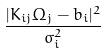<formula> <loc_0><loc_0><loc_500><loc_500>\frac { | K _ { i j } \Omega _ { j } - b _ { i } | ^ { 2 } } { \sigma _ { i } ^ { 2 } }</formula> 